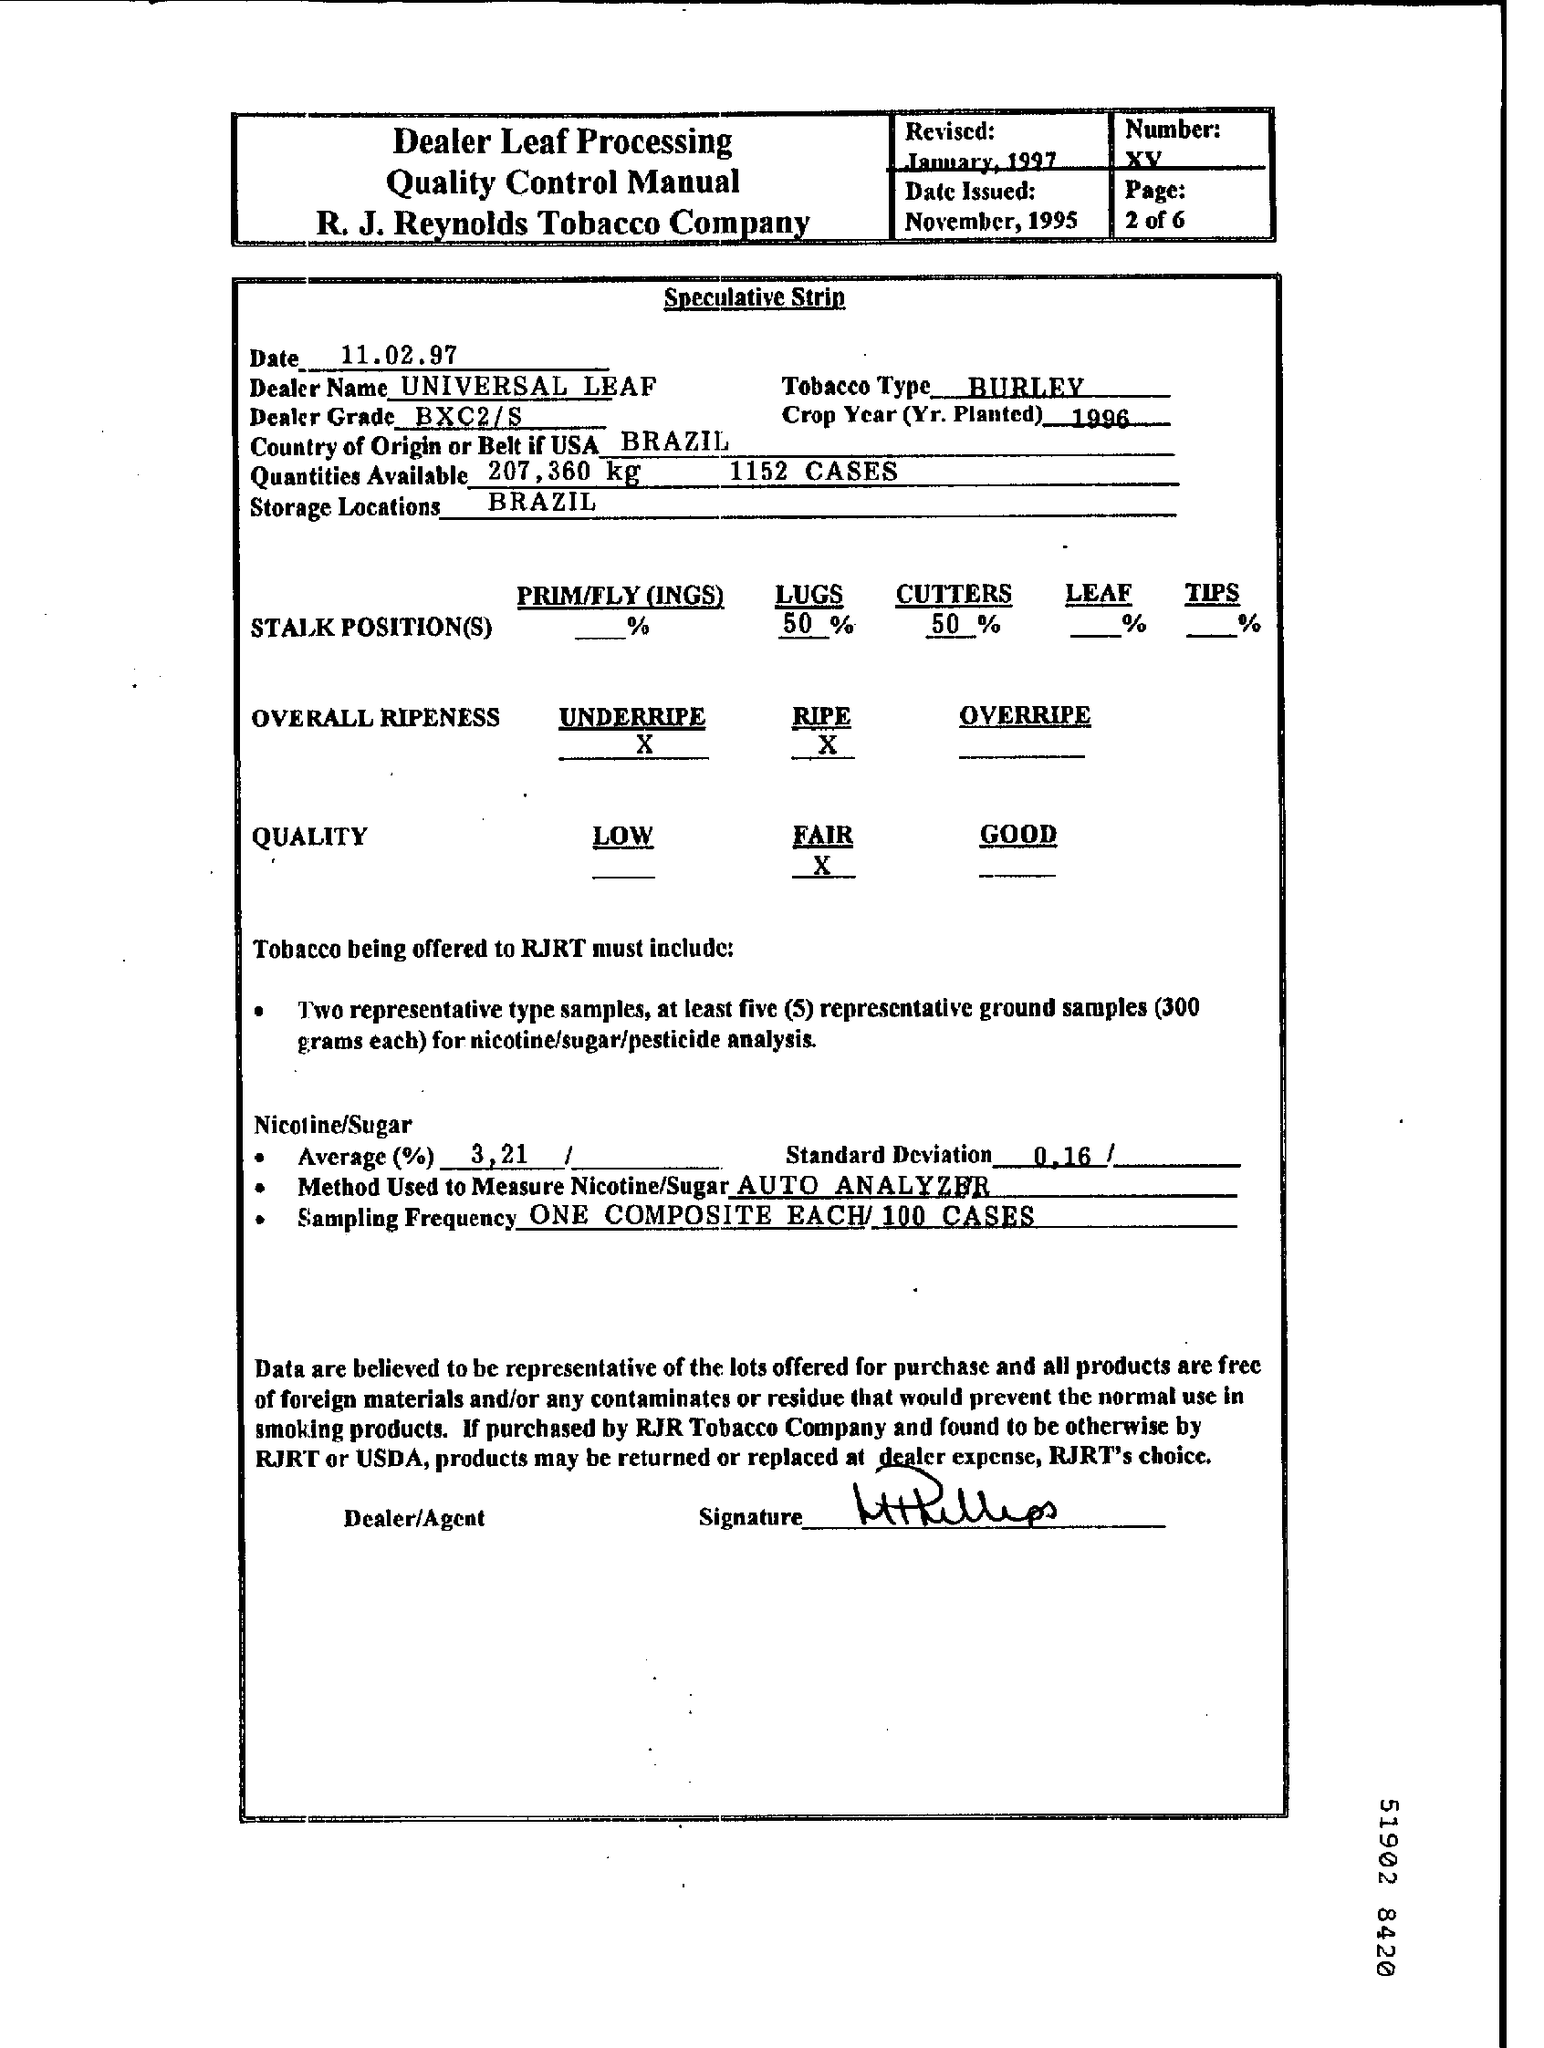Highlight a few significant elements in this photo. The storage locations are in Brazil. The date is 11.02.97. What is the number XV in the declaration? The crop year for which planting occurred in 1996 is known as the 1996 crop year. The country of origin or belt of the USA is Brazil. 